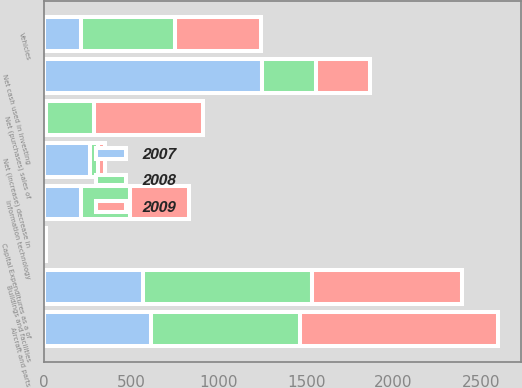Convert chart to OTSL. <chart><loc_0><loc_0><loc_500><loc_500><stacked_bar_chart><ecel><fcel>Net cash used in investing<fcel>Buildings and facilities<fcel>Aircraft and parts<fcel>Vehicles<fcel>Information technology<fcel>Capital Expenditures as a of<fcel>Net (increase) decrease in<fcel>Net (purchases) sales of<nl><fcel>2007<fcel>1248<fcel>568<fcel>611<fcel>209<fcel>214<fcel>3.5<fcel>261<fcel>11<nl><fcel>2008<fcel>308<fcel>968<fcel>852<fcel>539<fcel>277<fcel>5.1<fcel>49<fcel>278<nl><fcel>2009<fcel>308<fcel>853<fcel>1137<fcel>492<fcel>338<fcel>5.7<fcel>39<fcel>621<nl></chart> 